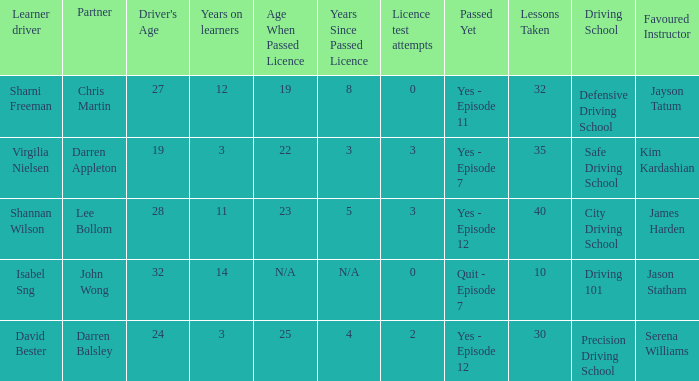Which driver is older than 24 and has more than 0 licence test attempts? Shannan Wilson. 